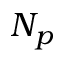<formula> <loc_0><loc_0><loc_500><loc_500>N _ { p }</formula> 